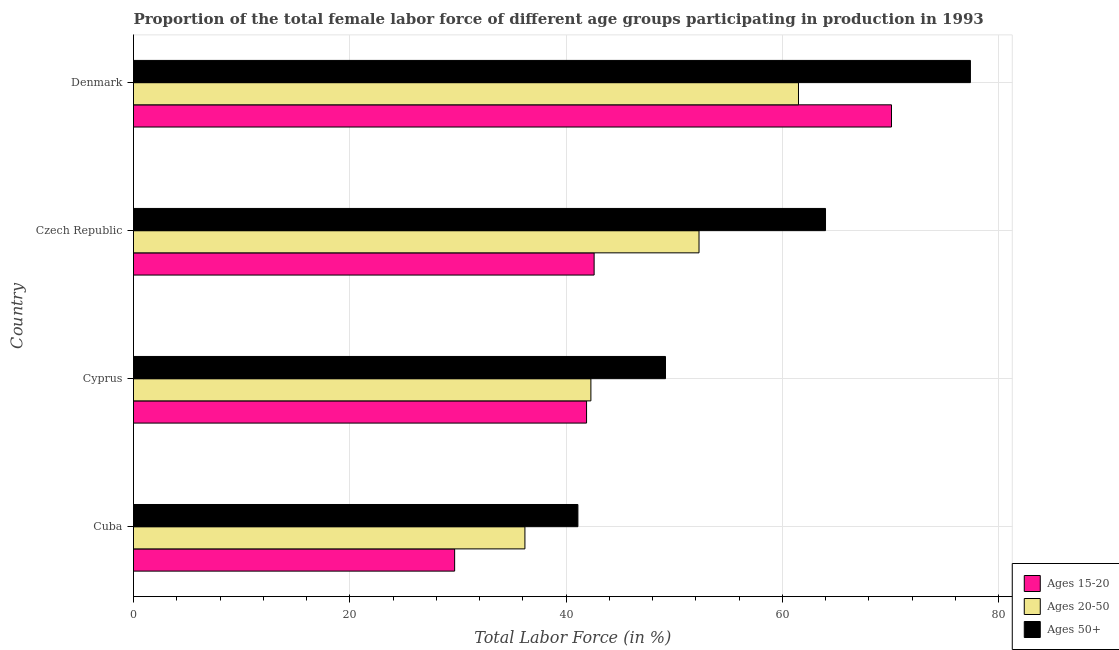How many different coloured bars are there?
Keep it short and to the point. 3. Are the number of bars on each tick of the Y-axis equal?
Ensure brevity in your answer.  Yes. How many bars are there on the 4th tick from the bottom?
Make the answer very short. 3. What is the label of the 4th group of bars from the top?
Give a very brief answer. Cuba. What is the percentage of female labor force above age 50 in Denmark?
Provide a succinct answer. 77.4. Across all countries, what is the maximum percentage of female labor force within the age group 15-20?
Provide a short and direct response. 70.1. Across all countries, what is the minimum percentage of female labor force above age 50?
Your response must be concise. 41.1. In which country was the percentage of female labor force within the age group 15-20 maximum?
Your answer should be very brief. Denmark. In which country was the percentage of female labor force within the age group 20-50 minimum?
Provide a succinct answer. Cuba. What is the total percentage of female labor force above age 50 in the graph?
Offer a terse response. 231.7. What is the difference between the percentage of female labor force within the age group 20-50 in Czech Republic and the percentage of female labor force within the age group 15-20 in Denmark?
Give a very brief answer. -17.8. What is the average percentage of female labor force above age 50 per country?
Offer a very short reply. 57.92. In how many countries, is the percentage of female labor force above age 50 greater than 56 %?
Your response must be concise. 2. What is the ratio of the percentage of female labor force within the age group 15-20 in Cyprus to that in Denmark?
Make the answer very short. 0.6. What is the difference between the highest and the lowest percentage of female labor force above age 50?
Offer a terse response. 36.3. In how many countries, is the percentage of female labor force within the age group 15-20 greater than the average percentage of female labor force within the age group 15-20 taken over all countries?
Ensure brevity in your answer.  1. Is the sum of the percentage of female labor force within the age group 20-50 in Cuba and Cyprus greater than the maximum percentage of female labor force above age 50 across all countries?
Offer a terse response. Yes. What does the 3rd bar from the top in Cuba represents?
Provide a succinct answer. Ages 15-20. What does the 2nd bar from the bottom in Czech Republic represents?
Make the answer very short. Ages 20-50. Is it the case that in every country, the sum of the percentage of female labor force within the age group 15-20 and percentage of female labor force within the age group 20-50 is greater than the percentage of female labor force above age 50?
Give a very brief answer. Yes. What is the difference between two consecutive major ticks on the X-axis?
Your answer should be compact. 20. Does the graph contain any zero values?
Provide a succinct answer. No. How many legend labels are there?
Ensure brevity in your answer.  3. How are the legend labels stacked?
Ensure brevity in your answer.  Vertical. What is the title of the graph?
Keep it short and to the point. Proportion of the total female labor force of different age groups participating in production in 1993. Does "Interest" appear as one of the legend labels in the graph?
Give a very brief answer. No. What is the label or title of the X-axis?
Offer a terse response. Total Labor Force (in %). What is the Total Labor Force (in %) of Ages 15-20 in Cuba?
Offer a terse response. 29.7. What is the Total Labor Force (in %) in Ages 20-50 in Cuba?
Your answer should be very brief. 36.2. What is the Total Labor Force (in %) in Ages 50+ in Cuba?
Provide a short and direct response. 41.1. What is the Total Labor Force (in %) of Ages 15-20 in Cyprus?
Give a very brief answer. 41.9. What is the Total Labor Force (in %) of Ages 20-50 in Cyprus?
Make the answer very short. 42.3. What is the Total Labor Force (in %) in Ages 50+ in Cyprus?
Your answer should be very brief. 49.2. What is the Total Labor Force (in %) in Ages 15-20 in Czech Republic?
Your answer should be compact. 42.6. What is the Total Labor Force (in %) in Ages 20-50 in Czech Republic?
Offer a terse response. 52.3. What is the Total Labor Force (in %) of Ages 50+ in Czech Republic?
Your response must be concise. 64. What is the Total Labor Force (in %) of Ages 15-20 in Denmark?
Your response must be concise. 70.1. What is the Total Labor Force (in %) of Ages 20-50 in Denmark?
Keep it short and to the point. 61.5. What is the Total Labor Force (in %) in Ages 50+ in Denmark?
Offer a very short reply. 77.4. Across all countries, what is the maximum Total Labor Force (in %) of Ages 15-20?
Give a very brief answer. 70.1. Across all countries, what is the maximum Total Labor Force (in %) in Ages 20-50?
Provide a short and direct response. 61.5. Across all countries, what is the maximum Total Labor Force (in %) of Ages 50+?
Your answer should be compact. 77.4. Across all countries, what is the minimum Total Labor Force (in %) of Ages 15-20?
Provide a succinct answer. 29.7. Across all countries, what is the minimum Total Labor Force (in %) in Ages 20-50?
Your response must be concise. 36.2. Across all countries, what is the minimum Total Labor Force (in %) of Ages 50+?
Provide a succinct answer. 41.1. What is the total Total Labor Force (in %) of Ages 15-20 in the graph?
Provide a succinct answer. 184.3. What is the total Total Labor Force (in %) of Ages 20-50 in the graph?
Keep it short and to the point. 192.3. What is the total Total Labor Force (in %) of Ages 50+ in the graph?
Your answer should be very brief. 231.7. What is the difference between the Total Labor Force (in %) in Ages 20-50 in Cuba and that in Cyprus?
Offer a terse response. -6.1. What is the difference between the Total Labor Force (in %) in Ages 50+ in Cuba and that in Cyprus?
Give a very brief answer. -8.1. What is the difference between the Total Labor Force (in %) in Ages 20-50 in Cuba and that in Czech Republic?
Keep it short and to the point. -16.1. What is the difference between the Total Labor Force (in %) in Ages 50+ in Cuba and that in Czech Republic?
Offer a terse response. -22.9. What is the difference between the Total Labor Force (in %) of Ages 15-20 in Cuba and that in Denmark?
Give a very brief answer. -40.4. What is the difference between the Total Labor Force (in %) in Ages 20-50 in Cuba and that in Denmark?
Offer a terse response. -25.3. What is the difference between the Total Labor Force (in %) of Ages 50+ in Cuba and that in Denmark?
Provide a succinct answer. -36.3. What is the difference between the Total Labor Force (in %) in Ages 15-20 in Cyprus and that in Czech Republic?
Offer a terse response. -0.7. What is the difference between the Total Labor Force (in %) of Ages 20-50 in Cyprus and that in Czech Republic?
Provide a succinct answer. -10. What is the difference between the Total Labor Force (in %) of Ages 50+ in Cyprus and that in Czech Republic?
Your response must be concise. -14.8. What is the difference between the Total Labor Force (in %) of Ages 15-20 in Cyprus and that in Denmark?
Provide a succinct answer. -28.2. What is the difference between the Total Labor Force (in %) of Ages 20-50 in Cyprus and that in Denmark?
Ensure brevity in your answer.  -19.2. What is the difference between the Total Labor Force (in %) in Ages 50+ in Cyprus and that in Denmark?
Offer a very short reply. -28.2. What is the difference between the Total Labor Force (in %) of Ages 15-20 in Czech Republic and that in Denmark?
Keep it short and to the point. -27.5. What is the difference between the Total Labor Force (in %) of Ages 20-50 in Czech Republic and that in Denmark?
Ensure brevity in your answer.  -9.2. What is the difference between the Total Labor Force (in %) of Ages 50+ in Czech Republic and that in Denmark?
Your response must be concise. -13.4. What is the difference between the Total Labor Force (in %) in Ages 15-20 in Cuba and the Total Labor Force (in %) in Ages 50+ in Cyprus?
Make the answer very short. -19.5. What is the difference between the Total Labor Force (in %) of Ages 20-50 in Cuba and the Total Labor Force (in %) of Ages 50+ in Cyprus?
Your response must be concise. -13. What is the difference between the Total Labor Force (in %) in Ages 15-20 in Cuba and the Total Labor Force (in %) in Ages 20-50 in Czech Republic?
Give a very brief answer. -22.6. What is the difference between the Total Labor Force (in %) of Ages 15-20 in Cuba and the Total Labor Force (in %) of Ages 50+ in Czech Republic?
Offer a very short reply. -34.3. What is the difference between the Total Labor Force (in %) of Ages 20-50 in Cuba and the Total Labor Force (in %) of Ages 50+ in Czech Republic?
Offer a terse response. -27.8. What is the difference between the Total Labor Force (in %) in Ages 15-20 in Cuba and the Total Labor Force (in %) in Ages 20-50 in Denmark?
Provide a short and direct response. -31.8. What is the difference between the Total Labor Force (in %) in Ages 15-20 in Cuba and the Total Labor Force (in %) in Ages 50+ in Denmark?
Give a very brief answer. -47.7. What is the difference between the Total Labor Force (in %) in Ages 20-50 in Cuba and the Total Labor Force (in %) in Ages 50+ in Denmark?
Offer a very short reply. -41.2. What is the difference between the Total Labor Force (in %) in Ages 15-20 in Cyprus and the Total Labor Force (in %) in Ages 20-50 in Czech Republic?
Make the answer very short. -10.4. What is the difference between the Total Labor Force (in %) of Ages 15-20 in Cyprus and the Total Labor Force (in %) of Ages 50+ in Czech Republic?
Offer a very short reply. -22.1. What is the difference between the Total Labor Force (in %) of Ages 20-50 in Cyprus and the Total Labor Force (in %) of Ages 50+ in Czech Republic?
Offer a terse response. -21.7. What is the difference between the Total Labor Force (in %) of Ages 15-20 in Cyprus and the Total Labor Force (in %) of Ages 20-50 in Denmark?
Give a very brief answer. -19.6. What is the difference between the Total Labor Force (in %) in Ages 15-20 in Cyprus and the Total Labor Force (in %) in Ages 50+ in Denmark?
Ensure brevity in your answer.  -35.5. What is the difference between the Total Labor Force (in %) of Ages 20-50 in Cyprus and the Total Labor Force (in %) of Ages 50+ in Denmark?
Your answer should be compact. -35.1. What is the difference between the Total Labor Force (in %) of Ages 15-20 in Czech Republic and the Total Labor Force (in %) of Ages 20-50 in Denmark?
Your response must be concise. -18.9. What is the difference between the Total Labor Force (in %) in Ages 15-20 in Czech Republic and the Total Labor Force (in %) in Ages 50+ in Denmark?
Ensure brevity in your answer.  -34.8. What is the difference between the Total Labor Force (in %) in Ages 20-50 in Czech Republic and the Total Labor Force (in %) in Ages 50+ in Denmark?
Your response must be concise. -25.1. What is the average Total Labor Force (in %) in Ages 15-20 per country?
Your answer should be very brief. 46.08. What is the average Total Labor Force (in %) in Ages 20-50 per country?
Your answer should be very brief. 48.08. What is the average Total Labor Force (in %) of Ages 50+ per country?
Provide a succinct answer. 57.92. What is the difference between the Total Labor Force (in %) of Ages 15-20 and Total Labor Force (in %) of Ages 50+ in Cuba?
Your response must be concise. -11.4. What is the difference between the Total Labor Force (in %) in Ages 15-20 and Total Labor Force (in %) in Ages 20-50 in Cyprus?
Provide a succinct answer. -0.4. What is the difference between the Total Labor Force (in %) of Ages 15-20 and Total Labor Force (in %) of Ages 50+ in Cyprus?
Give a very brief answer. -7.3. What is the difference between the Total Labor Force (in %) of Ages 15-20 and Total Labor Force (in %) of Ages 50+ in Czech Republic?
Make the answer very short. -21.4. What is the difference between the Total Labor Force (in %) in Ages 20-50 and Total Labor Force (in %) in Ages 50+ in Czech Republic?
Provide a succinct answer. -11.7. What is the difference between the Total Labor Force (in %) in Ages 15-20 and Total Labor Force (in %) in Ages 50+ in Denmark?
Give a very brief answer. -7.3. What is the difference between the Total Labor Force (in %) of Ages 20-50 and Total Labor Force (in %) of Ages 50+ in Denmark?
Give a very brief answer. -15.9. What is the ratio of the Total Labor Force (in %) of Ages 15-20 in Cuba to that in Cyprus?
Offer a terse response. 0.71. What is the ratio of the Total Labor Force (in %) in Ages 20-50 in Cuba to that in Cyprus?
Give a very brief answer. 0.86. What is the ratio of the Total Labor Force (in %) in Ages 50+ in Cuba to that in Cyprus?
Provide a succinct answer. 0.84. What is the ratio of the Total Labor Force (in %) of Ages 15-20 in Cuba to that in Czech Republic?
Your answer should be very brief. 0.7. What is the ratio of the Total Labor Force (in %) in Ages 20-50 in Cuba to that in Czech Republic?
Offer a very short reply. 0.69. What is the ratio of the Total Labor Force (in %) in Ages 50+ in Cuba to that in Czech Republic?
Give a very brief answer. 0.64. What is the ratio of the Total Labor Force (in %) in Ages 15-20 in Cuba to that in Denmark?
Your response must be concise. 0.42. What is the ratio of the Total Labor Force (in %) in Ages 20-50 in Cuba to that in Denmark?
Your answer should be compact. 0.59. What is the ratio of the Total Labor Force (in %) in Ages 50+ in Cuba to that in Denmark?
Your response must be concise. 0.53. What is the ratio of the Total Labor Force (in %) of Ages 15-20 in Cyprus to that in Czech Republic?
Offer a terse response. 0.98. What is the ratio of the Total Labor Force (in %) of Ages 20-50 in Cyprus to that in Czech Republic?
Provide a short and direct response. 0.81. What is the ratio of the Total Labor Force (in %) of Ages 50+ in Cyprus to that in Czech Republic?
Provide a short and direct response. 0.77. What is the ratio of the Total Labor Force (in %) in Ages 15-20 in Cyprus to that in Denmark?
Ensure brevity in your answer.  0.6. What is the ratio of the Total Labor Force (in %) of Ages 20-50 in Cyprus to that in Denmark?
Provide a succinct answer. 0.69. What is the ratio of the Total Labor Force (in %) of Ages 50+ in Cyprus to that in Denmark?
Keep it short and to the point. 0.64. What is the ratio of the Total Labor Force (in %) in Ages 15-20 in Czech Republic to that in Denmark?
Provide a short and direct response. 0.61. What is the ratio of the Total Labor Force (in %) of Ages 20-50 in Czech Republic to that in Denmark?
Make the answer very short. 0.85. What is the ratio of the Total Labor Force (in %) of Ages 50+ in Czech Republic to that in Denmark?
Provide a short and direct response. 0.83. What is the difference between the highest and the second highest Total Labor Force (in %) in Ages 50+?
Provide a short and direct response. 13.4. What is the difference between the highest and the lowest Total Labor Force (in %) of Ages 15-20?
Your answer should be compact. 40.4. What is the difference between the highest and the lowest Total Labor Force (in %) of Ages 20-50?
Your response must be concise. 25.3. What is the difference between the highest and the lowest Total Labor Force (in %) in Ages 50+?
Provide a short and direct response. 36.3. 